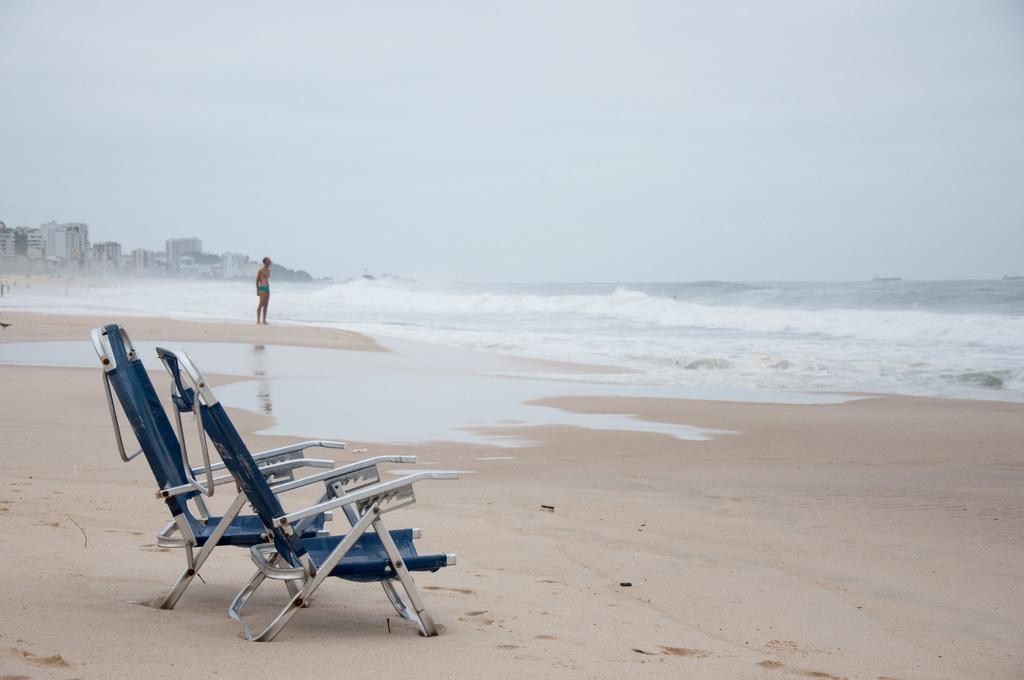Please provide a concise description of this image. In the image I can see a beach in which there are two chairs, person and also I can see some buildings to the side. 